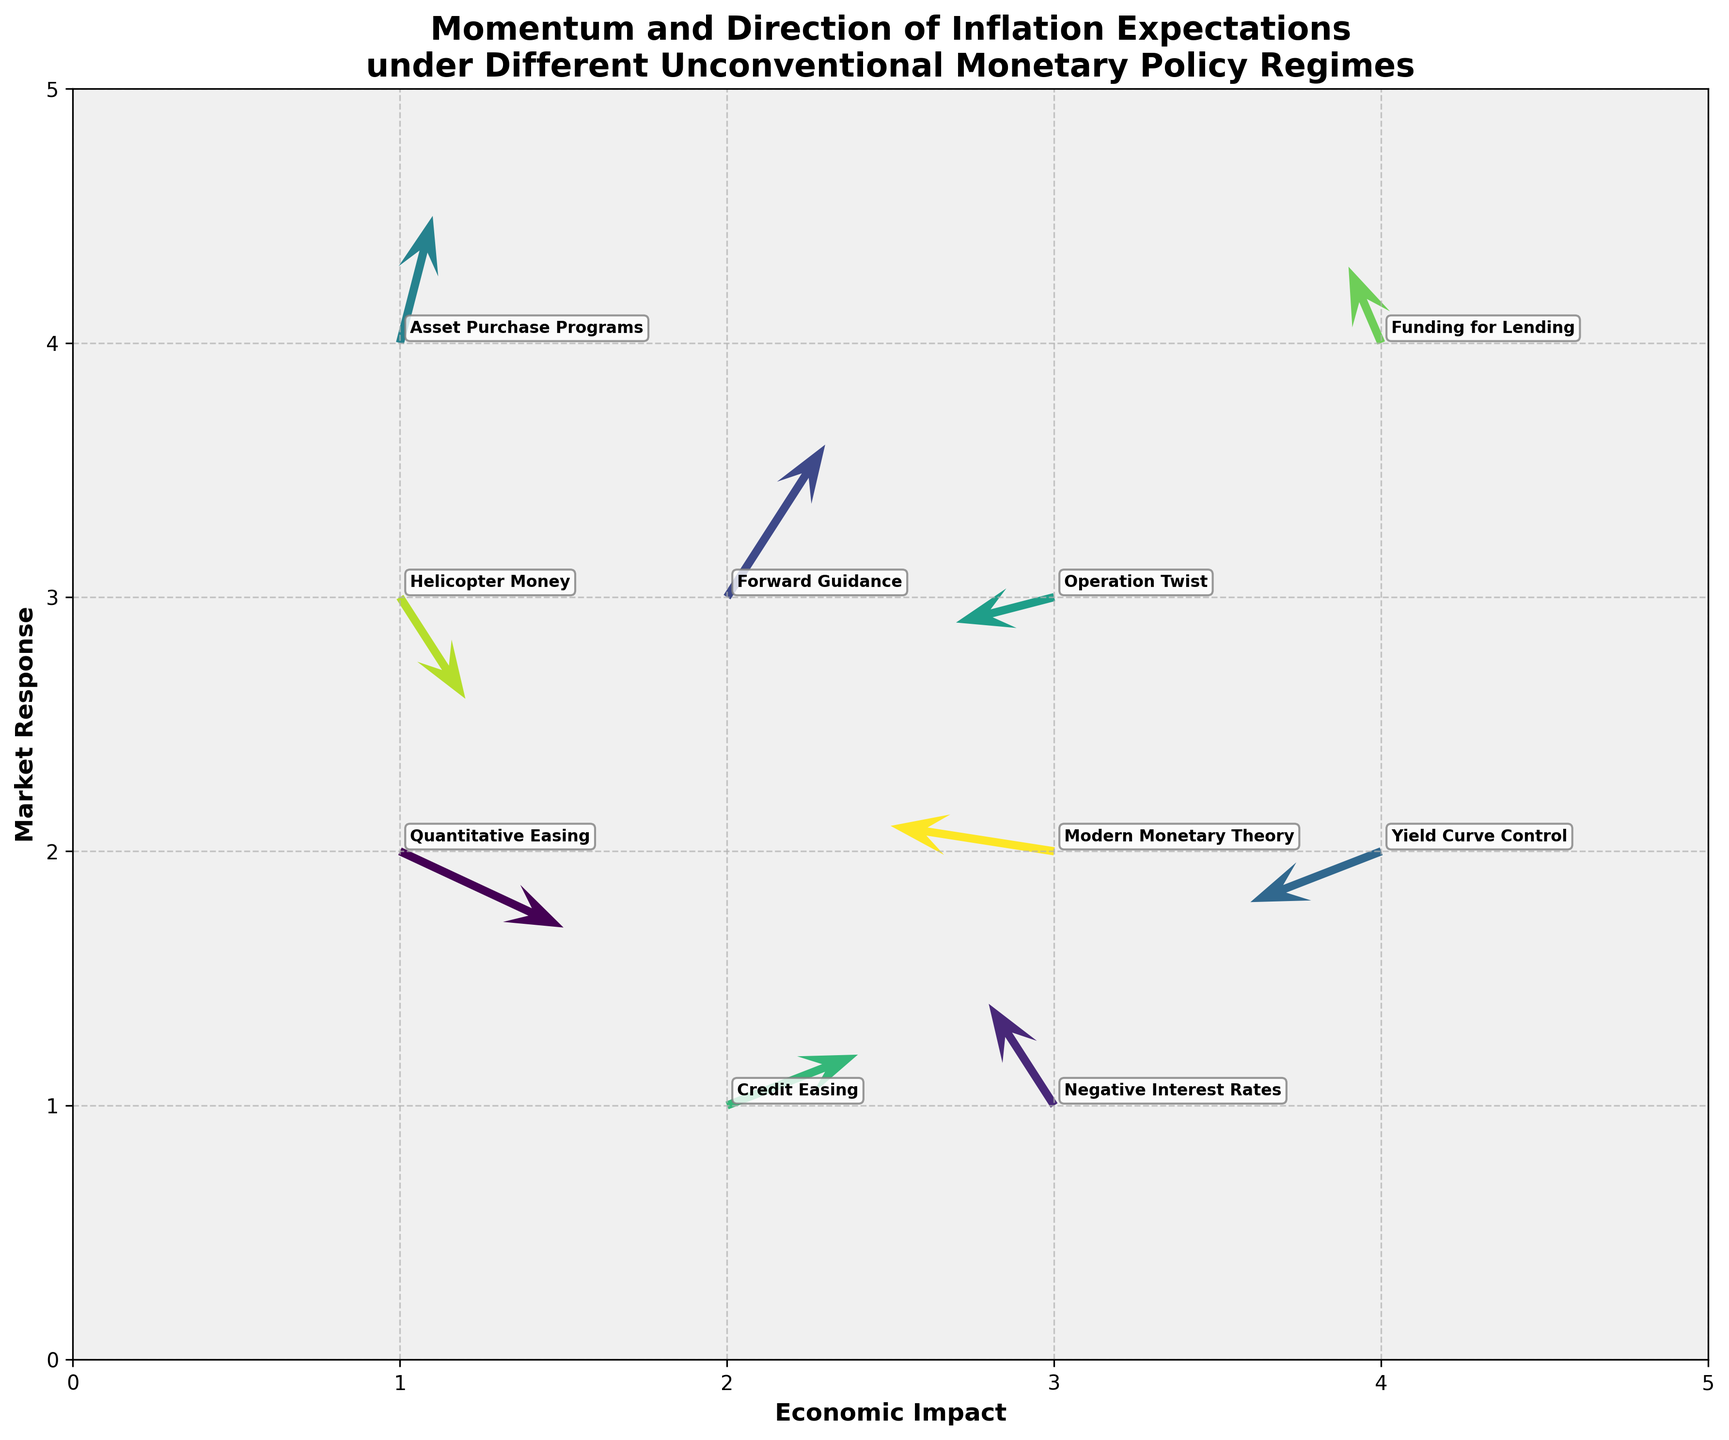What is the title of the figure? The title of the figure is displayed at the top and reads "Momentum and Direction of Inflation Expectations under Different Unconventional Monetary Policy Regimes".
Answer: Momentum and Direction of Inflation Expectations under Different Unconventional Monetary Policy Regimes How many policy regimes are visualized in the figure? Each arrow in the plot represents a different policy regime, and there are 10 arrows displayed.
Answer: 10 Which policy regime shows the largest upward market response? The length of the arrow along the y-axis indicates the market response. “Forward Guidance” has an arrow with a significant upward component (v=0.6), indicating the largest upward market response.
Answer: Forward Guidance Which policy regime has the most negative economic impact? The direction of the arrow along the x-axis indicates the economic impact. “Modern Monetary Theory” has the arrow with the most negative x-component (u=-0.5).
Answer: Modern Monetary Theory Where is the initial position of the policy regime "Operation Twist"? The initial position is where the arrow starts, defined by the x and y coordinates. For "Operation Twist", the initial point is (3, 3).
Answer: (3, 3) Which two policy regimes have arrows with a negative y-component? The y-component is determined by the v value. "Quantitative Easing" (v=-0.3) and "Helicopter Money" (v=-0.4) have negative y-components.
Answer: Quantitative Easing, Helicopter Money Compare the economic impact of "Yield Curve Control" and "Negative Interest Rates". Which one has a lesser impact? The economic impact is shown by the x-component (u). "Yield Curve Control" has u=-0.4 and "Negative Interest Rates" has u=-0.2. Since -0.4 is lesser than -0.2, "Yield Curve Control" has a lesser impact.
Answer: Yield Curve Control How does the market response of "Asset Purchase Programs" compare to "Credit Easing"? The market response is shown by the y-component (v). "Asset Purchase Programs" has v=0.5 and "Credit Easing" has v=0.2. Thus, the market response for "Asset Purchase Programs" is higher.
Answer: Asset Purchase Programs Quantify the combined horizontal shift (economic impact) of "Yield Curve Control" and "Forward Guidance". Summing the x-components (u values) of both arrows, for "Yield Curve Control" u=-0.4 and for "Forward Guidance" u=0.3, so the combined shift is -0.4 + 0.3 = -0.1.
Answer: -0.1 On the figure, which policy regime is located at the initial position (1, 3)? The initial positions are indicated by the (x, y) coordinates. The policy regime at (1, 3) is "Helicopter Money".
Answer: Helicopter Money 